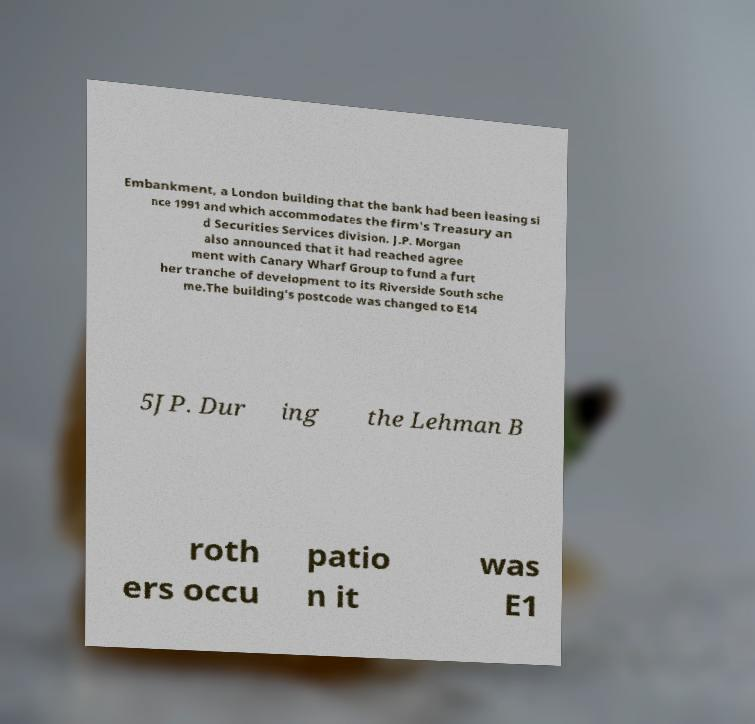I need the written content from this picture converted into text. Can you do that? Embankment, a London building that the bank had been leasing si nce 1991 and which accommodates the firm's Treasury an d Securities Services division. J.P. Morgan also announced that it had reached agree ment with Canary Wharf Group to fund a furt her tranche of development to its Riverside South sche me.The building's postcode was changed to E14 5JP. Dur ing the Lehman B roth ers occu patio n it was E1 